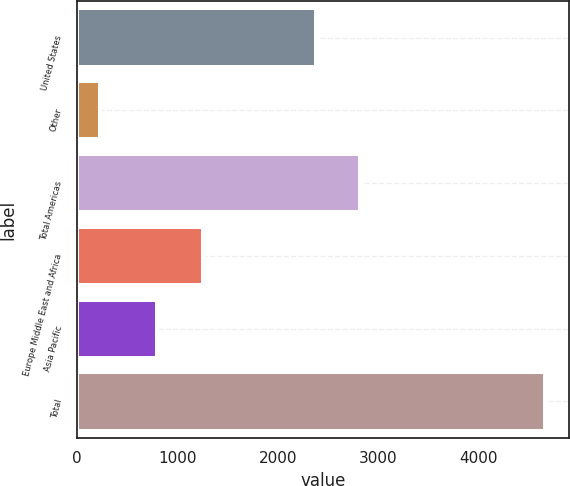<chart> <loc_0><loc_0><loc_500><loc_500><bar_chart><fcel>United States<fcel>Other<fcel>Total Americas<fcel>Europe Middle East and Africa<fcel>Asia Pacific<fcel>Total<nl><fcel>2381.5<fcel>232<fcel>2825.21<fcel>1256.9<fcel>798.7<fcel>4669.1<nl></chart> 